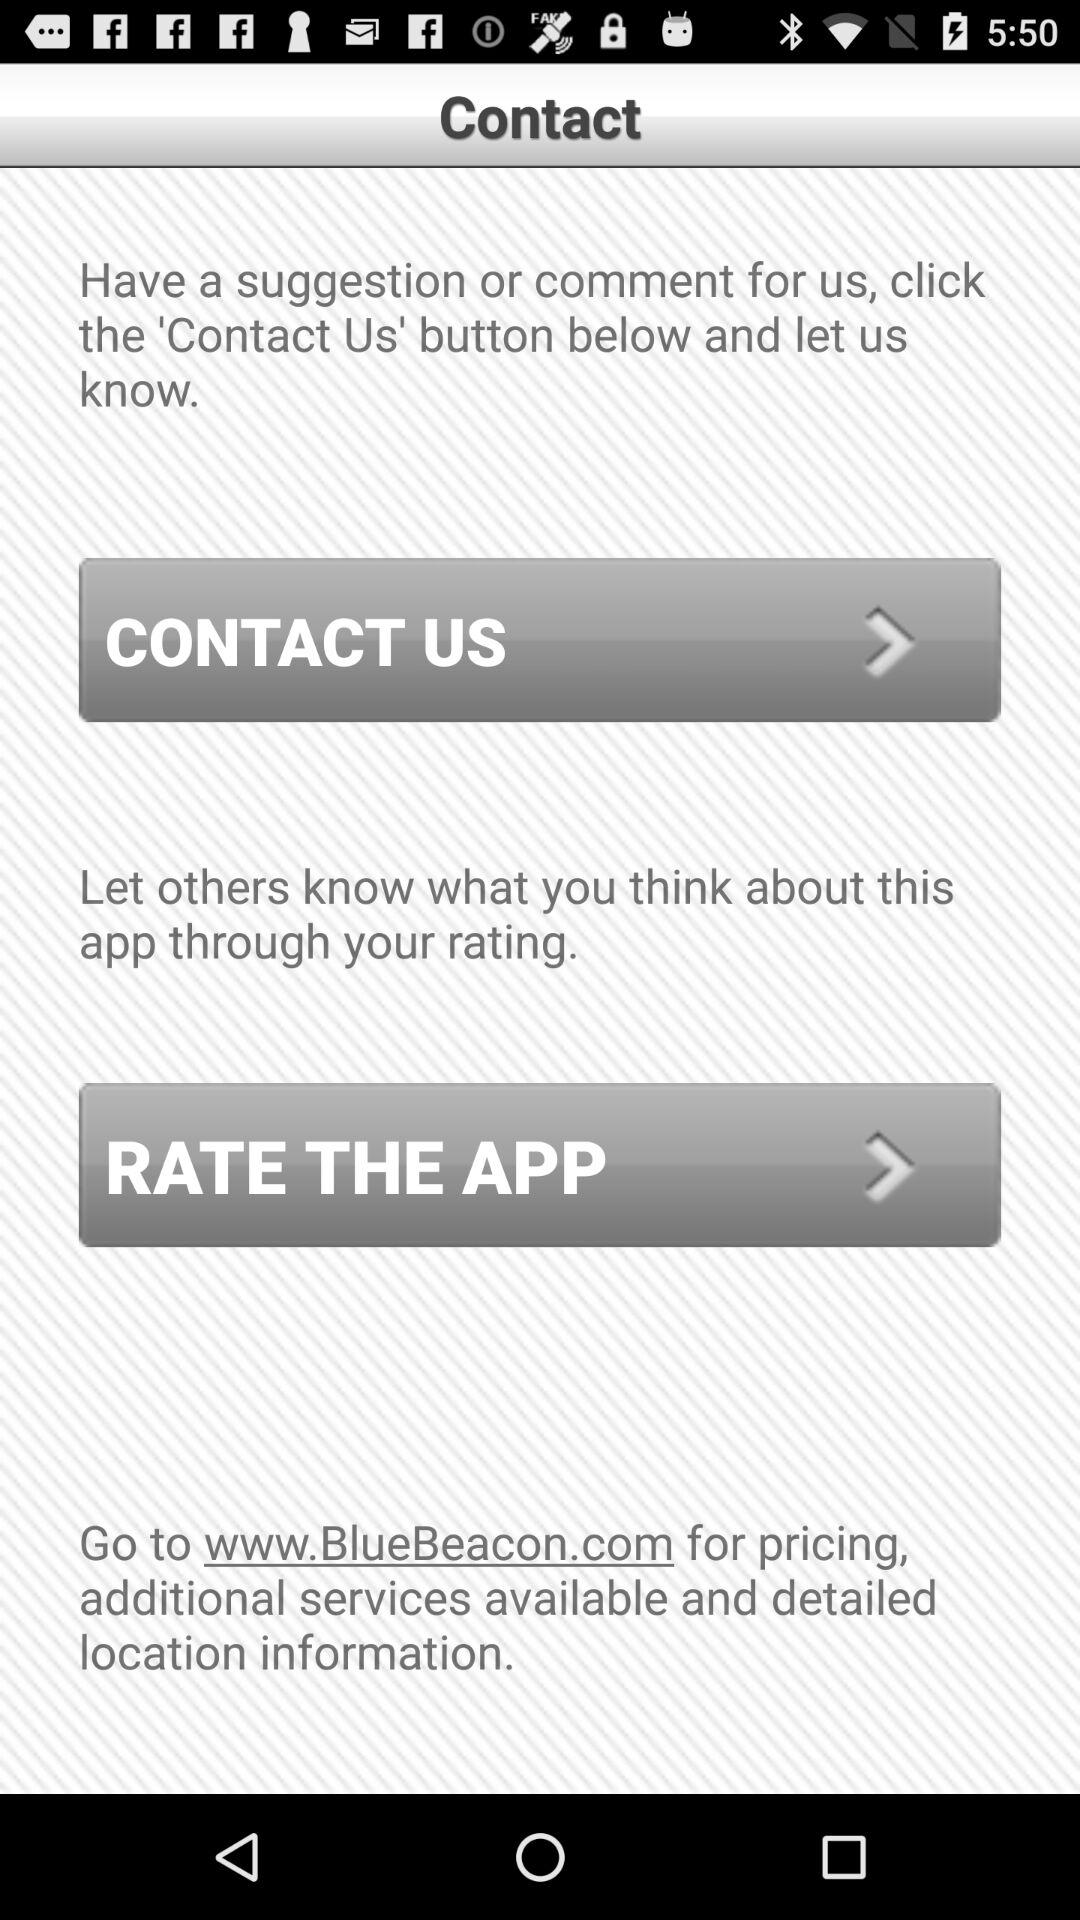What is the website name? The website name is BlueBeacon. 